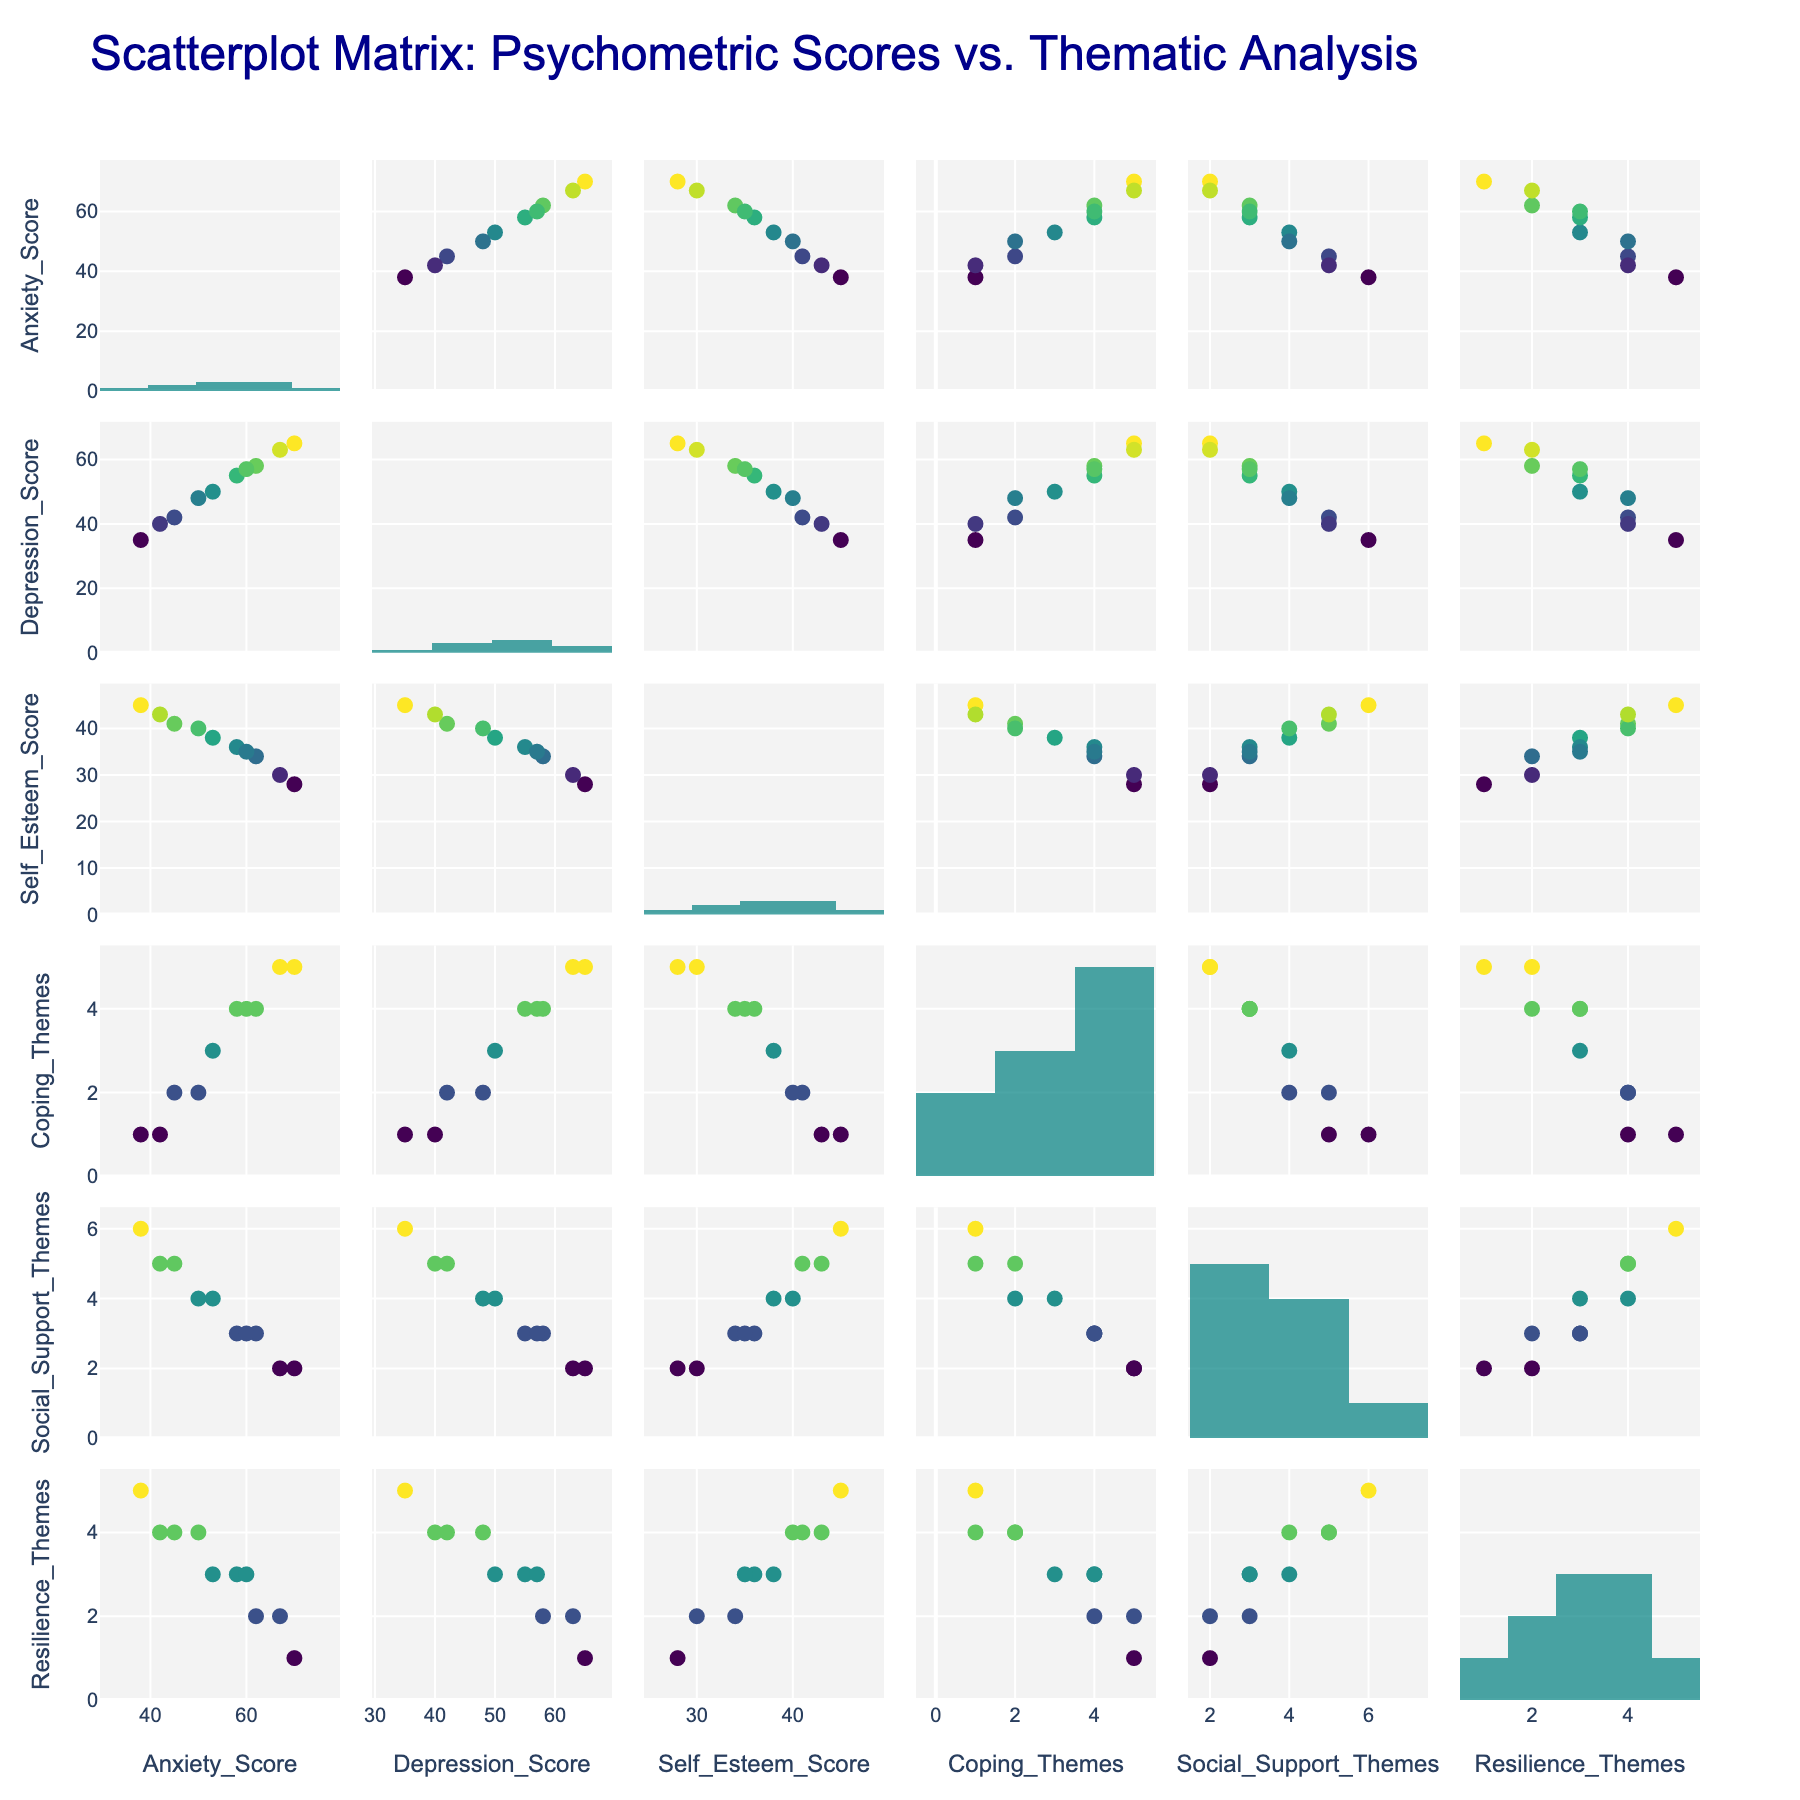What is the title of the scatterplot matrix? The title is prominently placed at the top of the figure and provides the main description of the scatterplot matrix.
Answer: Scatterplot Matrix: Psychometric Scores vs. Thematic Analysis How many variables are plotted in the scatterplot matrix? The scatterplot matrix includes both psychometric scores and thematic analysis themes, which can be counted by looking at the axis labels.
Answer: 6 What kind of color scale is used for the markers in scatterplots? The scatterplot markers' colors are based on a specific color scale that helps to distinguish the points. The name of the scale is often indicated in the legend or visible through the color gradient.
Answer: Viridis Which score appears to have the highest range of values based on the histograms? By observing the range covered by each histogram, one can determine which variable has the highest variation in values.
Answer: Anxiety_Score Is there any visible correlation between Anxiety_Score and Self_Esteem_Score? By examining the scatterplot for Anxiety_Score against Self_Esteem_Score, you can see if there is a trend or correlation (either positive or negative). Points forming a clear uptrend, downtrend, or no trend at all would indicate the type of correlation.
Answer: Negative correlation Which variables show a strong positive correlation? By looking for scatterplots where points form a clear upward trend, one can identify pairs of variables that are positively correlated.
Answer: Social_Support_Themes and Self_Esteem_Score What is the relationship between Depression_Score and Resilience_Themes? By examining the specific scatterplot between these two variables, one can infer the type of relationship (positive, negative, or none).
Answer: Negative correlation Which variable pair has the most number of data points clustering at high values? Determining which scatter plot in the matrix shows a concentration of points at high values for both variables.
Answer: Anxiety_Score and Depression_Score Do Social_Support_Themes and Coping_Themes appear to be correlated? By examining the scatterplot of Social_Support_Themes against Coping_Themes, one can observe if the points indicate any trend or correlation.
Answer: No clear correlation How does Resilience_Themes vary with Self_Esteem_Score? The relationship can be interpreted by looking at the respective scatterplot and finding trends indicating how one varies with the other.
Answer: Positive correlation 